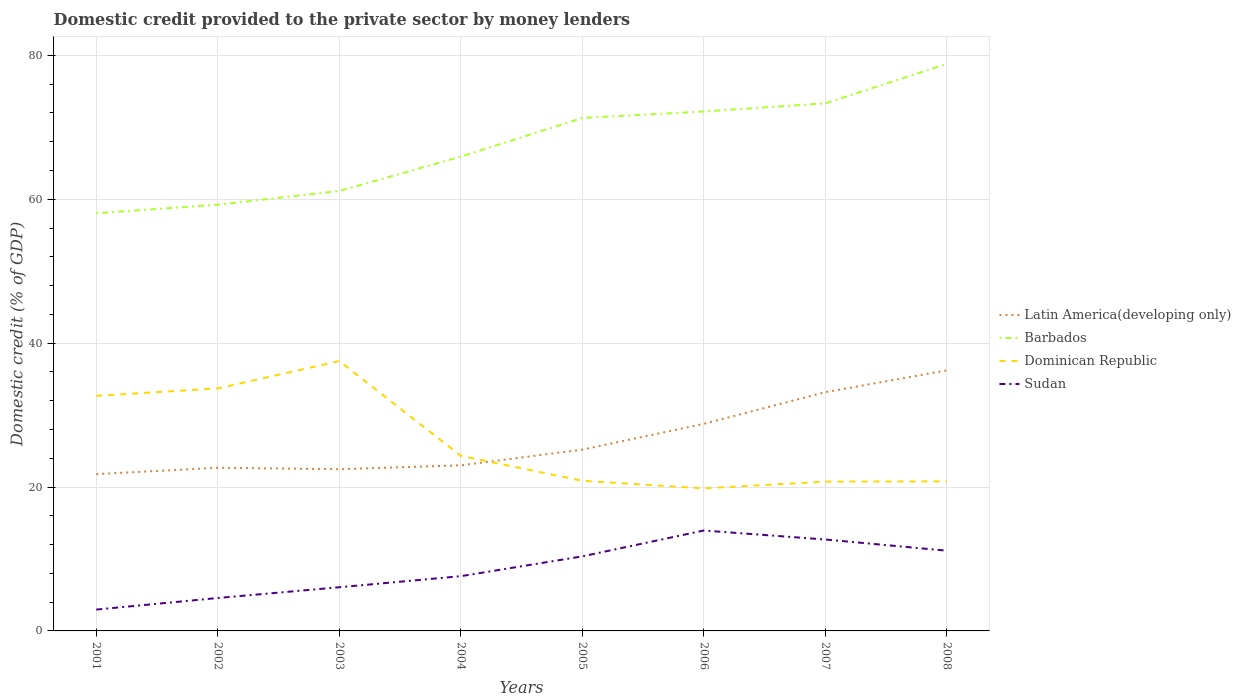Across all years, what is the maximum domestic credit provided to the private sector by money lenders in Barbados?
Provide a short and direct response. 58.07. What is the total domestic credit provided to the private sector by money lenders in Sudan in the graph?
Make the answer very short. 1.56. What is the difference between the highest and the second highest domestic credit provided to the private sector by money lenders in Dominican Republic?
Offer a very short reply. 17.7. Is the domestic credit provided to the private sector by money lenders in Barbados strictly greater than the domestic credit provided to the private sector by money lenders in Sudan over the years?
Provide a succinct answer. No. What is the difference between two consecutive major ticks on the Y-axis?
Your answer should be compact. 20. Are the values on the major ticks of Y-axis written in scientific E-notation?
Give a very brief answer. No. Does the graph contain any zero values?
Ensure brevity in your answer.  No. How many legend labels are there?
Make the answer very short. 4. How are the legend labels stacked?
Ensure brevity in your answer.  Vertical. What is the title of the graph?
Ensure brevity in your answer.  Domestic credit provided to the private sector by money lenders. Does "Djibouti" appear as one of the legend labels in the graph?
Offer a terse response. No. What is the label or title of the Y-axis?
Provide a succinct answer. Domestic credit (% of GDP). What is the Domestic credit (% of GDP) in Latin America(developing only) in 2001?
Ensure brevity in your answer.  21.8. What is the Domestic credit (% of GDP) of Barbados in 2001?
Provide a short and direct response. 58.07. What is the Domestic credit (% of GDP) in Dominican Republic in 2001?
Offer a terse response. 32.68. What is the Domestic credit (% of GDP) in Sudan in 2001?
Ensure brevity in your answer.  2.97. What is the Domestic credit (% of GDP) of Latin America(developing only) in 2002?
Provide a succinct answer. 22.68. What is the Domestic credit (% of GDP) of Barbados in 2002?
Ensure brevity in your answer.  59.25. What is the Domestic credit (% of GDP) in Dominican Republic in 2002?
Your answer should be compact. 33.71. What is the Domestic credit (% of GDP) of Sudan in 2002?
Offer a very short reply. 4.58. What is the Domestic credit (% of GDP) in Latin America(developing only) in 2003?
Your answer should be compact. 22.48. What is the Domestic credit (% of GDP) of Barbados in 2003?
Your answer should be very brief. 61.15. What is the Domestic credit (% of GDP) in Dominican Republic in 2003?
Give a very brief answer. 37.51. What is the Domestic credit (% of GDP) of Sudan in 2003?
Ensure brevity in your answer.  6.07. What is the Domestic credit (% of GDP) of Latin America(developing only) in 2004?
Your answer should be compact. 23.02. What is the Domestic credit (% of GDP) of Barbados in 2004?
Make the answer very short. 65.93. What is the Domestic credit (% of GDP) in Dominican Republic in 2004?
Offer a terse response. 24.34. What is the Domestic credit (% of GDP) in Sudan in 2004?
Offer a terse response. 7.61. What is the Domestic credit (% of GDP) of Latin America(developing only) in 2005?
Offer a very short reply. 25.2. What is the Domestic credit (% of GDP) of Barbados in 2005?
Provide a short and direct response. 71.31. What is the Domestic credit (% of GDP) of Dominican Republic in 2005?
Make the answer very short. 20.87. What is the Domestic credit (% of GDP) in Sudan in 2005?
Keep it short and to the point. 10.36. What is the Domestic credit (% of GDP) in Latin America(developing only) in 2006?
Give a very brief answer. 28.79. What is the Domestic credit (% of GDP) of Barbados in 2006?
Your answer should be very brief. 72.21. What is the Domestic credit (% of GDP) of Dominican Republic in 2006?
Make the answer very short. 19.82. What is the Domestic credit (% of GDP) of Sudan in 2006?
Give a very brief answer. 13.96. What is the Domestic credit (% of GDP) of Latin America(developing only) in 2007?
Your answer should be compact. 33.19. What is the Domestic credit (% of GDP) of Barbados in 2007?
Your answer should be compact. 73.35. What is the Domestic credit (% of GDP) of Dominican Republic in 2007?
Keep it short and to the point. 20.75. What is the Domestic credit (% of GDP) of Sudan in 2007?
Your answer should be very brief. 12.71. What is the Domestic credit (% of GDP) in Latin America(developing only) in 2008?
Ensure brevity in your answer.  36.22. What is the Domestic credit (% of GDP) of Barbados in 2008?
Offer a terse response. 78.83. What is the Domestic credit (% of GDP) in Dominican Republic in 2008?
Your answer should be very brief. 20.79. What is the Domestic credit (% of GDP) of Sudan in 2008?
Make the answer very short. 11.15. Across all years, what is the maximum Domestic credit (% of GDP) in Latin America(developing only)?
Provide a succinct answer. 36.22. Across all years, what is the maximum Domestic credit (% of GDP) in Barbados?
Offer a very short reply. 78.83. Across all years, what is the maximum Domestic credit (% of GDP) in Dominican Republic?
Keep it short and to the point. 37.51. Across all years, what is the maximum Domestic credit (% of GDP) in Sudan?
Your answer should be compact. 13.96. Across all years, what is the minimum Domestic credit (% of GDP) in Latin America(developing only)?
Keep it short and to the point. 21.8. Across all years, what is the minimum Domestic credit (% of GDP) in Barbados?
Give a very brief answer. 58.07. Across all years, what is the minimum Domestic credit (% of GDP) in Dominican Republic?
Provide a succinct answer. 19.82. Across all years, what is the minimum Domestic credit (% of GDP) in Sudan?
Provide a short and direct response. 2.97. What is the total Domestic credit (% of GDP) of Latin America(developing only) in the graph?
Provide a short and direct response. 213.38. What is the total Domestic credit (% of GDP) of Barbados in the graph?
Keep it short and to the point. 540.09. What is the total Domestic credit (% of GDP) of Dominican Republic in the graph?
Your answer should be very brief. 210.47. What is the total Domestic credit (% of GDP) of Sudan in the graph?
Keep it short and to the point. 69.41. What is the difference between the Domestic credit (% of GDP) in Latin America(developing only) in 2001 and that in 2002?
Your answer should be compact. -0.88. What is the difference between the Domestic credit (% of GDP) of Barbados in 2001 and that in 2002?
Provide a succinct answer. -1.18. What is the difference between the Domestic credit (% of GDP) of Dominican Republic in 2001 and that in 2002?
Provide a succinct answer. -1.04. What is the difference between the Domestic credit (% of GDP) in Sudan in 2001 and that in 2002?
Give a very brief answer. -1.61. What is the difference between the Domestic credit (% of GDP) in Latin America(developing only) in 2001 and that in 2003?
Keep it short and to the point. -0.68. What is the difference between the Domestic credit (% of GDP) of Barbados in 2001 and that in 2003?
Ensure brevity in your answer.  -3.08. What is the difference between the Domestic credit (% of GDP) of Dominican Republic in 2001 and that in 2003?
Keep it short and to the point. -4.84. What is the difference between the Domestic credit (% of GDP) of Sudan in 2001 and that in 2003?
Make the answer very short. -3.11. What is the difference between the Domestic credit (% of GDP) in Latin America(developing only) in 2001 and that in 2004?
Ensure brevity in your answer.  -1.23. What is the difference between the Domestic credit (% of GDP) of Barbados in 2001 and that in 2004?
Ensure brevity in your answer.  -7.86. What is the difference between the Domestic credit (% of GDP) in Dominican Republic in 2001 and that in 2004?
Offer a terse response. 8.33. What is the difference between the Domestic credit (% of GDP) in Sudan in 2001 and that in 2004?
Your response must be concise. -4.64. What is the difference between the Domestic credit (% of GDP) in Latin America(developing only) in 2001 and that in 2005?
Ensure brevity in your answer.  -3.4. What is the difference between the Domestic credit (% of GDP) of Barbados in 2001 and that in 2005?
Offer a very short reply. -13.24. What is the difference between the Domestic credit (% of GDP) in Dominican Republic in 2001 and that in 2005?
Give a very brief answer. 11.8. What is the difference between the Domestic credit (% of GDP) in Sudan in 2001 and that in 2005?
Make the answer very short. -7.4. What is the difference between the Domestic credit (% of GDP) in Latin America(developing only) in 2001 and that in 2006?
Give a very brief answer. -6.99. What is the difference between the Domestic credit (% of GDP) of Barbados in 2001 and that in 2006?
Your answer should be very brief. -14.14. What is the difference between the Domestic credit (% of GDP) of Dominican Republic in 2001 and that in 2006?
Make the answer very short. 12.86. What is the difference between the Domestic credit (% of GDP) in Sudan in 2001 and that in 2006?
Your answer should be very brief. -10.99. What is the difference between the Domestic credit (% of GDP) in Latin America(developing only) in 2001 and that in 2007?
Offer a very short reply. -11.39. What is the difference between the Domestic credit (% of GDP) in Barbados in 2001 and that in 2007?
Offer a very short reply. -15.28. What is the difference between the Domestic credit (% of GDP) of Dominican Republic in 2001 and that in 2007?
Provide a succinct answer. 11.92. What is the difference between the Domestic credit (% of GDP) of Sudan in 2001 and that in 2007?
Your response must be concise. -9.74. What is the difference between the Domestic credit (% of GDP) in Latin America(developing only) in 2001 and that in 2008?
Ensure brevity in your answer.  -14.43. What is the difference between the Domestic credit (% of GDP) of Barbados in 2001 and that in 2008?
Keep it short and to the point. -20.76. What is the difference between the Domestic credit (% of GDP) in Dominican Republic in 2001 and that in 2008?
Offer a very short reply. 11.89. What is the difference between the Domestic credit (% of GDP) in Sudan in 2001 and that in 2008?
Provide a succinct answer. -8.19. What is the difference between the Domestic credit (% of GDP) of Latin America(developing only) in 2002 and that in 2003?
Provide a succinct answer. 0.2. What is the difference between the Domestic credit (% of GDP) in Barbados in 2002 and that in 2003?
Give a very brief answer. -1.91. What is the difference between the Domestic credit (% of GDP) in Dominican Republic in 2002 and that in 2003?
Your answer should be compact. -3.8. What is the difference between the Domestic credit (% of GDP) in Sudan in 2002 and that in 2003?
Offer a very short reply. -1.49. What is the difference between the Domestic credit (% of GDP) of Latin America(developing only) in 2002 and that in 2004?
Ensure brevity in your answer.  -0.35. What is the difference between the Domestic credit (% of GDP) of Barbados in 2002 and that in 2004?
Offer a very short reply. -6.68. What is the difference between the Domestic credit (% of GDP) in Dominican Republic in 2002 and that in 2004?
Provide a succinct answer. 9.37. What is the difference between the Domestic credit (% of GDP) in Sudan in 2002 and that in 2004?
Make the answer very short. -3.03. What is the difference between the Domestic credit (% of GDP) in Latin America(developing only) in 2002 and that in 2005?
Provide a succinct answer. -2.52. What is the difference between the Domestic credit (% of GDP) of Barbados in 2002 and that in 2005?
Ensure brevity in your answer.  -12.06. What is the difference between the Domestic credit (% of GDP) of Dominican Republic in 2002 and that in 2005?
Make the answer very short. 12.84. What is the difference between the Domestic credit (% of GDP) in Sudan in 2002 and that in 2005?
Your answer should be very brief. -5.79. What is the difference between the Domestic credit (% of GDP) in Latin America(developing only) in 2002 and that in 2006?
Your answer should be very brief. -6.11. What is the difference between the Domestic credit (% of GDP) of Barbados in 2002 and that in 2006?
Make the answer very short. -12.96. What is the difference between the Domestic credit (% of GDP) in Dominican Republic in 2002 and that in 2006?
Your response must be concise. 13.89. What is the difference between the Domestic credit (% of GDP) in Sudan in 2002 and that in 2006?
Make the answer very short. -9.38. What is the difference between the Domestic credit (% of GDP) in Latin America(developing only) in 2002 and that in 2007?
Ensure brevity in your answer.  -10.51. What is the difference between the Domestic credit (% of GDP) in Barbados in 2002 and that in 2007?
Make the answer very short. -14.1. What is the difference between the Domestic credit (% of GDP) of Dominican Republic in 2002 and that in 2007?
Your response must be concise. 12.96. What is the difference between the Domestic credit (% of GDP) of Sudan in 2002 and that in 2007?
Provide a succinct answer. -8.13. What is the difference between the Domestic credit (% of GDP) of Latin America(developing only) in 2002 and that in 2008?
Your answer should be very brief. -13.55. What is the difference between the Domestic credit (% of GDP) of Barbados in 2002 and that in 2008?
Your answer should be very brief. -19.58. What is the difference between the Domestic credit (% of GDP) in Dominican Republic in 2002 and that in 2008?
Provide a succinct answer. 12.93. What is the difference between the Domestic credit (% of GDP) in Sudan in 2002 and that in 2008?
Offer a very short reply. -6.58. What is the difference between the Domestic credit (% of GDP) in Latin America(developing only) in 2003 and that in 2004?
Your answer should be compact. -0.54. What is the difference between the Domestic credit (% of GDP) of Barbados in 2003 and that in 2004?
Keep it short and to the point. -4.77. What is the difference between the Domestic credit (% of GDP) in Dominican Republic in 2003 and that in 2004?
Offer a terse response. 13.17. What is the difference between the Domestic credit (% of GDP) of Sudan in 2003 and that in 2004?
Provide a succinct answer. -1.54. What is the difference between the Domestic credit (% of GDP) in Latin America(developing only) in 2003 and that in 2005?
Offer a very short reply. -2.72. What is the difference between the Domestic credit (% of GDP) in Barbados in 2003 and that in 2005?
Keep it short and to the point. -10.15. What is the difference between the Domestic credit (% of GDP) in Dominican Republic in 2003 and that in 2005?
Offer a very short reply. 16.64. What is the difference between the Domestic credit (% of GDP) in Sudan in 2003 and that in 2005?
Offer a terse response. -4.29. What is the difference between the Domestic credit (% of GDP) of Latin America(developing only) in 2003 and that in 2006?
Give a very brief answer. -6.31. What is the difference between the Domestic credit (% of GDP) of Barbados in 2003 and that in 2006?
Your answer should be compact. -11.05. What is the difference between the Domestic credit (% of GDP) in Dominican Republic in 2003 and that in 2006?
Give a very brief answer. 17.7. What is the difference between the Domestic credit (% of GDP) in Sudan in 2003 and that in 2006?
Make the answer very short. -7.89. What is the difference between the Domestic credit (% of GDP) in Latin America(developing only) in 2003 and that in 2007?
Provide a succinct answer. -10.71. What is the difference between the Domestic credit (% of GDP) of Barbados in 2003 and that in 2007?
Offer a very short reply. -12.19. What is the difference between the Domestic credit (% of GDP) of Dominican Republic in 2003 and that in 2007?
Your answer should be compact. 16.76. What is the difference between the Domestic credit (% of GDP) of Sudan in 2003 and that in 2007?
Provide a succinct answer. -6.64. What is the difference between the Domestic credit (% of GDP) in Latin America(developing only) in 2003 and that in 2008?
Give a very brief answer. -13.74. What is the difference between the Domestic credit (% of GDP) of Barbados in 2003 and that in 2008?
Provide a succinct answer. -17.67. What is the difference between the Domestic credit (% of GDP) in Dominican Republic in 2003 and that in 2008?
Ensure brevity in your answer.  16.73. What is the difference between the Domestic credit (% of GDP) in Sudan in 2003 and that in 2008?
Your response must be concise. -5.08. What is the difference between the Domestic credit (% of GDP) of Latin America(developing only) in 2004 and that in 2005?
Give a very brief answer. -2.18. What is the difference between the Domestic credit (% of GDP) of Barbados in 2004 and that in 2005?
Make the answer very short. -5.38. What is the difference between the Domestic credit (% of GDP) in Dominican Republic in 2004 and that in 2005?
Make the answer very short. 3.47. What is the difference between the Domestic credit (% of GDP) of Sudan in 2004 and that in 2005?
Offer a terse response. -2.75. What is the difference between the Domestic credit (% of GDP) of Latin America(developing only) in 2004 and that in 2006?
Your response must be concise. -5.76. What is the difference between the Domestic credit (% of GDP) in Barbados in 2004 and that in 2006?
Provide a short and direct response. -6.28. What is the difference between the Domestic credit (% of GDP) of Dominican Republic in 2004 and that in 2006?
Provide a short and direct response. 4.52. What is the difference between the Domestic credit (% of GDP) in Sudan in 2004 and that in 2006?
Ensure brevity in your answer.  -6.35. What is the difference between the Domestic credit (% of GDP) in Latin America(developing only) in 2004 and that in 2007?
Provide a short and direct response. -10.17. What is the difference between the Domestic credit (% of GDP) of Barbados in 2004 and that in 2007?
Give a very brief answer. -7.42. What is the difference between the Domestic credit (% of GDP) of Dominican Republic in 2004 and that in 2007?
Keep it short and to the point. 3.59. What is the difference between the Domestic credit (% of GDP) of Sudan in 2004 and that in 2007?
Give a very brief answer. -5.1. What is the difference between the Domestic credit (% of GDP) of Latin America(developing only) in 2004 and that in 2008?
Give a very brief answer. -13.2. What is the difference between the Domestic credit (% of GDP) of Barbados in 2004 and that in 2008?
Your answer should be compact. -12.9. What is the difference between the Domestic credit (% of GDP) in Dominican Republic in 2004 and that in 2008?
Provide a short and direct response. 3.56. What is the difference between the Domestic credit (% of GDP) in Sudan in 2004 and that in 2008?
Your answer should be compact. -3.54. What is the difference between the Domestic credit (% of GDP) in Latin America(developing only) in 2005 and that in 2006?
Provide a succinct answer. -3.59. What is the difference between the Domestic credit (% of GDP) of Barbados in 2005 and that in 2006?
Offer a very short reply. -0.9. What is the difference between the Domestic credit (% of GDP) of Dominican Republic in 2005 and that in 2006?
Provide a succinct answer. 1.05. What is the difference between the Domestic credit (% of GDP) in Sudan in 2005 and that in 2006?
Offer a terse response. -3.6. What is the difference between the Domestic credit (% of GDP) of Latin America(developing only) in 2005 and that in 2007?
Your answer should be very brief. -7.99. What is the difference between the Domestic credit (% of GDP) in Barbados in 2005 and that in 2007?
Provide a succinct answer. -2.04. What is the difference between the Domestic credit (% of GDP) in Dominican Republic in 2005 and that in 2007?
Offer a very short reply. 0.12. What is the difference between the Domestic credit (% of GDP) in Sudan in 2005 and that in 2007?
Make the answer very short. -2.34. What is the difference between the Domestic credit (% of GDP) in Latin America(developing only) in 2005 and that in 2008?
Give a very brief answer. -11.02. What is the difference between the Domestic credit (% of GDP) of Barbados in 2005 and that in 2008?
Your answer should be very brief. -7.52. What is the difference between the Domestic credit (% of GDP) in Dominican Republic in 2005 and that in 2008?
Keep it short and to the point. 0.09. What is the difference between the Domestic credit (% of GDP) of Sudan in 2005 and that in 2008?
Your answer should be compact. -0.79. What is the difference between the Domestic credit (% of GDP) of Latin America(developing only) in 2006 and that in 2007?
Provide a succinct answer. -4.4. What is the difference between the Domestic credit (% of GDP) in Barbados in 2006 and that in 2007?
Ensure brevity in your answer.  -1.14. What is the difference between the Domestic credit (% of GDP) of Dominican Republic in 2006 and that in 2007?
Offer a terse response. -0.94. What is the difference between the Domestic credit (% of GDP) of Sudan in 2006 and that in 2007?
Your answer should be very brief. 1.25. What is the difference between the Domestic credit (% of GDP) in Latin America(developing only) in 2006 and that in 2008?
Provide a succinct answer. -7.44. What is the difference between the Domestic credit (% of GDP) in Barbados in 2006 and that in 2008?
Provide a succinct answer. -6.62. What is the difference between the Domestic credit (% of GDP) in Dominican Republic in 2006 and that in 2008?
Provide a succinct answer. -0.97. What is the difference between the Domestic credit (% of GDP) of Sudan in 2006 and that in 2008?
Your answer should be very brief. 2.81. What is the difference between the Domestic credit (% of GDP) in Latin America(developing only) in 2007 and that in 2008?
Give a very brief answer. -3.03. What is the difference between the Domestic credit (% of GDP) of Barbados in 2007 and that in 2008?
Keep it short and to the point. -5.48. What is the difference between the Domestic credit (% of GDP) of Dominican Republic in 2007 and that in 2008?
Ensure brevity in your answer.  -0.03. What is the difference between the Domestic credit (% of GDP) of Sudan in 2007 and that in 2008?
Provide a succinct answer. 1.56. What is the difference between the Domestic credit (% of GDP) of Latin America(developing only) in 2001 and the Domestic credit (% of GDP) of Barbados in 2002?
Your answer should be compact. -37.45. What is the difference between the Domestic credit (% of GDP) in Latin America(developing only) in 2001 and the Domestic credit (% of GDP) in Dominican Republic in 2002?
Your answer should be very brief. -11.91. What is the difference between the Domestic credit (% of GDP) in Latin America(developing only) in 2001 and the Domestic credit (% of GDP) in Sudan in 2002?
Provide a succinct answer. 17.22. What is the difference between the Domestic credit (% of GDP) in Barbados in 2001 and the Domestic credit (% of GDP) in Dominican Republic in 2002?
Your response must be concise. 24.36. What is the difference between the Domestic credit (% of GDP) of Barbados in 2001 and the Domestic credit (% of GDP) of Sudan in 2002?
Offer a terse response. 53.49. What is the difference between the Domestic credit (% of GDP) in Dominican Republic in 2001 and the Domestic credit (% of GDP) in Sudan in 2002?
Provide a succinct answer. 28.1. What is the difference between the Domestic credit (% of GDP) in Latin America(developing only) in 2001 and the Domestic credit (% of GDP) in Barbados in 2003?
Your response must be concise. -39.36. What is the difference between the Domestic credit (% of GDP) in Latin America(developing only) in 2001 and the Domestic credit (% of GDP) in Dominican Republic in 2003?
Your answer should be compact. -15.72. What is the difference between the Domestic credit (% of GDP) in Latin America(developing only) in 2001 and the Domestic credit (% of GDP) in Sudan in 2003?
Make the answer very short. 15.73. What is the difference between the Domestic credit (% of GDP) of Barbados in 2001 and the Domestic credit (% of GDP) of Dominican Republic in 2003?
Provide a succinct answer. 20.56. What is the difference between the Domestic credit (% of GDP) in Barbados in 2001 and the Domestic credit (% of GDP) in Sudan in 2003?
Give a very brief answer. 52. What is the difference between the Domestic credit (% of GDP) of Dominican Republic in 2001 and the Domestic credit (% of GDP) of Sudan in 2003?
Provide a succinct answer. 26.6. What is the difference between the Domestic credit (% of GDP) of Latin America(developing only) in 2001 and the Domestic credit (% of GDP) of Barbados in 2004?
Make the answer very short. -44.13. What is the difference between the Domestic credit (% of GDP) of Latin America(developing only) in 2001 and the Domestic credit (% of GDP) of Dominican Republic in 2004?
Your answer should be very brief. -2.54. What is the difference between the Domestic credit (% of GDP) of Latin America(developing only) in 2001 and the Domestic credit (% of GDP) of Sudan in 2004?
Ensure brevity in your answer.  14.19. What is the difference between the Domestic credit (% of GDP) in Barbados in 2001 and the Domestic credit (% of GDP) in Dominican Republic in 2004?
Your response must be concise. 33.73. What is the difference between the Domestic credit (% of GDP) of Barbados in 2001 and the Domestic credit (% of GDP) of Sudan in 2004?
Offer a terse response. 50.46. What is the difference between the Domestic credit (% of GDP) in Dominican Republic in 2001 and the Domestic credit (% of GDP) in Sudan in 2004?
Your answer should be very brief. 25.07. What is the difference between the Domestic credit (% of GDP) of Latin America(developing only) in 2001 and the Domestic credit (% of GDP) of Barbados in 2005?
Make the answer very short. -49.51. What is the difference between the Domestic credit (% of GDP) of Latin America(developing only) in 2001 and the Domestic credit (% of GDP) of Dominican Republic in 2005?
Provide a short and direct response. 0.93. What is the difference between the Domestic credit (% of GDP) in Latin America(developing only) in 2001 and the Domestic credit (% of GDP) in Sudan in 2005?
Offer a very short reply. 11.43. What is the difference between the Domestic credit (% of GDP) in Barbados in 2001 and the Domestic credit (% of GDP) in Dominican Republic in 2005?
Give a very brief answer. 37.2. What is the difference between the Domestic credit (% of GDP) of Barbados in 2001 and the Domestic credit (% of GDP) of Sudan in 2005?
Give a very brief answer. 47.71. What is the difference between the Domestic credit (% of GDP) of Dominican Republic in 2001 and the Domestic credit (% of GDP) of Sudan in 2005?
Offer a very short reply. 22.31. What is the difference between the Domestic credit (% of GDP) in Latin America(developing only) in 2001 and the Domestic credit (% of GDP) in Barbados in 2006?
Keep it short and to the point. -50.41. What is the difference between the Domestic credit (% of GDP) in Latin America(developing only) in 2001 and the Domestic credit (% of GDP) in Dominican Republic in 2006?
Offer a very short reply. 1.98. What is the difference between the Domestic credit (% of GDP) in Latin America(developing only) in 2001 and the Domestic credit (% of GDP) in Sudan in 2006?
Your answer should be compact. 7.84. What is the difference between the Domestic credit (% of GDP) in Barbados in 2001 and the Domestic credit (% of GDP) in Dominican Republic in 2006?
Offer a terse response. 38.25. What is the difference between the Domestic credit (% of GDP) of Barbados in 2001 and the Domestic credit (% of GDP) of Sudan in 2006?
Your answer should be very brief. 44.11. What is the difference between the Domestic credit (% of GDP) in Dominican Republic in 2001 and the Domestic credit (% of GDP) in Sudan in 2006?
Give a very brief answer. 18.72. What is the difference between the Domestic credit (% of GDP) in Latin America(developing only) in 2001 and the Domestic credit (% of GDP) in Barbados in 2007?
Give a very brief answer. -51.55. What is the difference between the Domestic credit (% of GDP) of Latin America(developing only) in 2001 and the Domestic credit (% of GDP) of Dominican Republic in 2007?
Provide a succinct answer. 1.04. What is the difference between the Domestic credit (% of GDP) of Latin America(developing only) in 2001 and the Domestic credit (% of GDP) of Sudan in 2007?
Your answer should be very brief. 9.09. What is the difference between the Domestic credit (% of GDP) in Barbados in 2001 and the Domestic credit (% of GDP) in Dominican Republic in 2007?
Make the answer very short. 37.32. What is the difference between the Domestic credit (% of GDP) in Barbados in 2001 and the Domestic credit (% of GDP) in Sudan in 2007?
Provide a succinct answer. 45.36. What is the difference between the Domestic credit (% of GDP) of Dominican Republic in 2001 and the Domestic credit (% of GDP) of Sudan in 2007?
Your answer should be compact. 19.97. What is the difference between the Domestic credit (% of GDP) in Latin America(developing only) in 2001 and the Domestic credit (% of GDP) in Barbados in 2008?
Offer a very short reply. -57.03. What is the difference between the Domestic credit (% of GDP) in Latin America(developing only) in 2001 and the Domestic credit (% of GDP) in Dominican Republic in 2008?
Offer a terse response. 1.01. What is the difference between the Domestic credit (% of GDP) in Latin America(developing only) in 2001 and the Domestic credit (% of GDP) in Sudan in 2008?
Provide a succinct answer. 10.64. What is the difference between the Domestic credit (% of GDP) in Barbados in 2001 and the Domestic credit (% of GDP) in Dominican Republic in 2008?
Ensure brevity in your answer.  37.28. What is the difference between the Domestic credit (% of GDP) of Barbados in 2001 and the Domestic credit (% of GDP) of Sudan in 2008?
Provide a short and direct response. 46.92. What is the difference between the Domestic credit (% of GDP) of Dominican Republic in 2001 and the Domestic credit (% of GDP) of Sudan in 2008?
Give a very brief answer. 21.52. What is the difference between the Domestic credit (% of GDP) of Latin America(developing only) in 2002 and the Domestic credit (% of GDP) of Barbados in 2003?
Ensure brevity in your answer.  -38.48. What is the difference between the Domestic credit (% of GDP) in Latin America(developing only) in 2002 and the Domestic credit (% of GDP) in Dominican Republic in 2003?
Your answer should be compact. -14.84. What is the difference between the Domestic credit (% of GDP) of Latin America(developing only) in 2002 and the Domestic credit (% of GDP) of Sudan in 2003?
Give a very brief answer. 16.61. What is the difference between the Domestic credit (% of GDP) in Barbados in 2002 and the Domestic credit (% of GDP) in Dominican Republic in 2003?
Your response must be concise. 21.74. What is the difference between the Domestic credit (% of GDP) in Barbados in 2002 and the Domestic credit (% of GDP) in Sudan in 2003?
Your response must be concise. 53.18. What is the difference between the Domestic credit (% of GDP) of Dominican Republic in 2002 and the Domestic credit (% of GDP) of Sudan in 2003?
Make the answer very short. 27.64. What is the difference between the Domestic credit (% of GDP) in Latin America(developing only) in 2002 and the Domestic credit (% of GDP) in Barbados in 2004?
Your response must be concise. -43.25. What is the difference between the Domestic credit (% of GDP) of Latin America(developing only) in 2002 and the Domestic credit (% of GDP) of Dominican Republic in 2004?
Offer a terse response. -1.66. What is the difference between the Domestic credit (% of GDP) of Latin America(developing only) in 2002 and the Domestic credit (% of GDP) of Sudan in 2004?
Offer a very short reply. 15.07. What is the difference between the Domestic credit (% of GDP) of Barbados in 2002 and the Domestic credit (% of GDP) of Dominican Republic in 2004?
Offer a terse response. 34.91. What is the difference between the Domestic credit (% of GDP) of Barbados in 2002 and the Domestic credit (% of GDP) of Sudan in 2004?
Your answer should be very brief. 51.64. What is the difference between the Domestic credit (% of GDP) of Dominican Republic in 2002 and the Domestic credit (% of GDP) of Sudan in 2004?
Keep it short and to the point. 26.1. What is the difference between the Domestic credit (% of GDP) in Latin America(developing only) in 2002 and the Domestic credit (% of GDP) in Barbados in 2005?
Give a very brief answer. -48.63. What is the difference between the Domestic credit (% of GDP) of Latin America(developing only) in 2002 and the Domestic credit (% of GDP) of Dominican Republic in 2005?
Your response must be concise. 1.81. What is the difference between the Domestic credit (% of GDP) of Latin America(developing only) in 2002 and the Domestic credit (% of GDP) of Sudan in 2005?
Offer a terse response. 12.31. What is the difference between the Domestic credit (% of GDP) of Barbados in 2002 and the Domestic credit (% of GDP) of Dominican Republic in 2005?
Make the answer very short. 38.38. What is the difference between the Domestic credit (% of GDP) in Barbados in 2002 and the Domestic credit (% of GDP) in Sudan in 2005?
Your answer should be very brief. 48.88. What is the difference between the Domestic credit (% of GDP) in Dominican Republic in 2002 and the Domestic credit (% of GDP) in Sudan in 2005?
Make the answer very short. 23.35. What is the difference between the Domestic credit (% of GDP) of Latin America(developing only) in 2002 and the Domestic credit (% of GDP) of Barbados in 2006?
Your answer should be compact. -49.53. What is the difference between the Domestic credit (% of GDP) in Latin America(developing only) in 2002 and the Domestic credit (% of GDP) in Dominican Republic in 2006?
Your answer should be very brief. 2.86. What is the difference between the Domestic credit (% of GDP) of Latin America(developing only) in 2002 and the Domestic credit (% of GDP) of Sudan in 2006?
Keep it short and to the point. 8.72. What is the difference between the Domestic credit (% of GDP) of Barbados in 2002 and the Domestic credit (% of GDP) of Dominican Republic in 2006?
Your response must be concise. 39.43. What is the difference between the Domestic credit (% of GDP) of Barbados in 2002 and the Domestic credit (% of GDP) of Sudan in 2006?
Give a very brief answer. 45.29. What is the difference between the Domestic credit (% of GDP) of Dominican Republic in 2002 and the Domestic credit (% of GDP) of Sudan in 2006?
Give a very brief answer. 19.75. What is the difference between the Domestic credit (% of GDP) of Latin America(developing only) in 2002 and the Domestic credit (% of GDP) of Barbados in 2007?
Ensure brevity in your answer.  -50.67. What is the difference between the Domestic credit (% of GDP) of Latin America(developing only) in 2002 and the Domestic credit (% of GDP) of Dominican Republic in 2007?
Your response must be concise. 1.92. What is the difference between the Domestic credit (% of GDP) of Latin America(developing only) in 2002 and the Domestic credit (% of GDP) of Sudan in 2007?
Your answer should be compact. 9.97. What is the difference between the Domestic credit (% of GDP) of Barbados in 2002 and the Domestic credit (% of GDP) of Dominican Republic in 2007?
Provide a succinct answer. 38.5. What is the difference between the Domestic credit (% of GDP) in Barbados in 2002 and the Domestic credit (% of GDP) in Sudan in 2007?
Ensure brevity in your answer.  46.54. What is the difference between the Domestic credit (% of GDP) in Dominican Republic in 2002 and the Domestic credit (% of GDP) in Sudan in 2007?
Offer a very short reply. 21. What is the difference between the Domestic credit (% of GDP) in Latin America(developing only) in 2002 and the Domestic credit (% of GDP) in Barbados in 2008?
Offer a terse response. -56.15. What is the difference between the Domestic credit (% of GDP) of Latin America(developing only) in 2002 and the Domestic credit (% of GDP) of Dominican Republic in 2008?
Provide a short and direct response. 1.89. What is the difference between the Domestic credit (% of GDP) of Latin America(developing only) in 2002 and the Domestic credit (% of GDP) of Sudan in 2008?
Offer a terse response. 11.52. What is the difference between the Domestic credit (% of GDP) in Barbados in 2002 and the Domestic credit (% of GDP) in Dominican Republic in 2008?
Ensure brevity in your answer.  38.46. What is the difference between the Domestic credit (% of GDP) in Barbados in 2002 and the Domestic credit (% of GDP) in Sudan in 2008?
Provide a short and direct response. 48.1. What is the difference between the Domestic credit (% of GDP) in Dominican Republic in 2002 and the Domestic credit (% of GDP) in Sudan in 2008?
Make the answer very short. 22.56. What is the difference between the Domestic credit (% of GDP) in Latin America(developing only) in 2003 and the Domestic credit (% of GDP) in Barbados in 2004?
Keep it short and to the point. -43.45. What is the difference between the Domestic credit (% of GDP) in Latin America(developing only) in 2003 and the Domestic credit (% of GDP) in Dominican Republic in 2004?
Give a very brief answer. -1.86. What is the difference between the Domestic credit (% of GDP) of Latin America(developing only) in 2003 and the Domestic credit (% of GDP) of Sudan in 2004?
Provide a succinct answer. 14.87. What is the difference between the Domestic credit (% of GDP) in Barbados in 2003 and the Domestic credit (% of GDP) in Dominican Republic in 2004?
Offer a terse response. 36.81. What is the difference between the Domestic credit (% of GDP) in Barbados in 2003 and the Domestic credit (% of GDP) in Sudan in 2004?
Provide a short and direct response. 53.54. What is the difference between the Domestic credit (% of GDP) in Dominican Republic in 2003 and the Domestic credit (% of GDP) in Sudan in 2004?
Ensure brevity in your answer.  29.9. What is the difference between the Domestic credit (% of GDP) of Latin America(developing only) in 2003 and the Domestic credit (% of GDP) of Barbados in 2005?
Offer a terse response. -48.83. What is the difference between the Domestic credit (% of GDP) of Latin America(developing only) in 2003 and the Domestic credit (% of GDP) of Dominican Republic in 2005?
Your response must be concise. 1.61. What is the difference between the Domestic credit (% of GDP) in Latin America(developing only) in 2003 and the Domestic credit (% of GDP) in Sudan in 2005?
Provide a succinct answer. 12.12. What is the difference between the Domestic credit (% of GDP) in Barbados in 2003 and the Domestic credit (% of GDP) in Dominican Republic in 2005?
Offer a terse response. 40.28. What is the difference between the Domestic credit (% of GDP) in Barbados in 2003 and the Domestic credit (% of GDP) in Sudan in 2005?
Provide a short and direct response. 50.79. What is the difference between the Domestic credit (% of GDP) in Dominican Republic in 2003 and the Domestic credit (% of GDP) in Sudan in 2005?
Offer a terse response. 27.15. What is the difference between the Domestic credit (% of GDP) of Latin America(developing only) in 2003 and the Domestic credit (% of GDP) of Barbados in 2006?
Your answer should be compact. -49.73. What is the difference between the Domestic credit (% of GDP) in Latin America(developing only) in 2003 and the Domestic credit (% of GDP) in Dominican Republic in 2006?
Offer a terse response. 2.66. What is the difference between the Domestic credit (% of GDP) of Latin America(developing only) in 2003 and the Domestic credit (% of GDP) of Sudan in 2006?
Give a very brief answer. 8.52. What is the difference between the Domestic credit (% of GDP) in Barbados in 2003 and the Domestic credit (% of GDP) in Dominican Republic in 2006?
Provide a short and direct response. 41.34. What is the difference between the Domestic credit (% of GDP) in Barbados in 2003 and the Domestic credit (% of GDP) in Sudan in 2006?
Keep it short and to the point. 47.19. What is the difference between the Domestic credit (% of GDP) in Dominican Republic in 2003 and the Domestic credit (% of GDP) in Sudan in 2006?
Give a very brief answer. 23.55. What is the difference between the Domestic credit (% of GDP) of Latin America(developing only) in 2003 and the Domestic credit (% of GDP) of Barbados in 2007?
Make the answer very short. -50.87. What is the difference between the Domestic credit (% of GDP) of Latin America(developing only) in 2003 and the Domestic credit (% of GDP) of Dominican Republic in 2007?
Offer a terse response. 1.73. What is the difference between the Domestic credit (% of GDP) in Latin America(developing only) in 2003 and the Domestic credit (% of GDP) in Sudan in 2007?
Offer a very short reply. 9.77. What is the difference between the Domestic credit (% of GDP) of Barbados in 2003 and the Domestic credit (% of GDP) of Dominican Republic in 2007?
Give a very brief answer. 40.4. What is the difference between the Domestic credit (% of GDP) in Barbados in 2003 and the Domestic credit (% of GDP) in Sudan in 2007?
Provide a succinct answer. 48.45. What is the difference between the Domestic credit (% of GDP) in Dominican Republic in 2003 and the Domestic credit (% of GDP) in Sudan in 2007?
Make the answer very short. 24.8. What is the difference between the Domestic credit (% of GDP) in Latin America(developing only) in 2003 and the Domestic credit (% of GDP) in Barbados in 2008?
Your answer should be very brief. -56.35. What is the difference between the Domestic credit (% of GDP) in Latin America(developing only) in 2003 and the Domestic credit (% of GDP) in Dominican Republic in 2008?
Ensure brevity in your answer.  1.69. What is the difference between the Domestic credit (% of GDP) in Latin America(developing only) in 2003 and the Domestic credit (% of GDP) in Sudan in 2008?
Ensure brevity in your answer.  11.33. What is the difference between the Domestic credit (% of GDP) of Barbados in 2003 and the Domestic credit (% of GDP) of Dominican Republic in 2008?
Offer a terse response. 40.37. What is the difference between the Domestic credit (% of GDP) in Barbados in 2003 and the Domestic credit (% of GDP) in Sudan in 2008?
Provide a succinct answer. 50. What is the difference between the Domestic credit (% of GDP) of Dominican Republic in 2003 and the Domestic credit (% of GDP) of Sudan in 2008?
Offer a very short reply. 26.36. What is the difference between the Domestic credit (% of GDP) of Latin America(developing only) in 2004 and the Domestic credit (% of GDP) of Barbados in 2005?
Your response must be concise. -48.29. What is the difference between the Domestic credit (% of GDP) of Latin America(developing only) in 2004 and the Domestic credit (% of GDP) of Dominican Republic in 2005?
Provide a succinct answer. 2.15. What is the difference between the Domestic credit (% of GDP) of Latin America(developing only) in 2004 and the Domestic credit (% of GDP) of Sudan in 2005?
Offer a terse response. 12.66. What is the difference between the Domestic credit (% of GDP) of Barbados in 2004 and the Domestic credit (% of GDP) of Dominican Republic in 2005?
Offer a terse response. 45.06. What is the difference between the Domestic credit (% of GDP) in Barbados in 2004 and the Domestic credit (% of GDP) in Sudan in 2005?
Provide a succinct answer. 55.56. What is the difference between the Domestic credit (% of GDP) of Dominican Republic in 2004 and the Domestic credit (% of GDP) of Sudan in 2005?
Ensure brevity in your answer.  13.98. What is the difference between the Domestic credit (% of GDP) of Latin America(developing only) in 2004 and the Domestic credit (% of GDP) of Barbados in 2006?
Offer a very short reply. -49.18. What is the difference between the Domestic credit (% of GDP) in Latin America(developing only) in 2004 and the Domestic credit (% of GDP) in Dominican Republic in 2006?
Provide a short and direct response. 3.21. What is the difference between the Domestic credit (% of GDP) of Latin America(developing only) in 2004 and the Domestic credit (% of GDP) of Sudan in 2006?
Offer a terse response. 9.06. What is the difference between the Domestic credit (% of GDP) of Barbados in 2004 and the Domestic credit (% of GDP) of Dominican Republic in 2006?
Keep it short and to the point. 46.11. What is the difference between the Domestic credit (% of GDP) of Barbados in 2004 and the Domestic credit (% of GDP) of Sudan in 2006?
Your answer should be very brief. 51.97. What is the difference between the Domestic credit (% of GDP) in Dominican Republic in 2004 and the Domestic credit (% of GDP) in Sudan in 2006?
Your answer should be very brief. 10.38. What is the difference between the Domestic credit (% of GDP) of Latin America(developing only) in 2004 and the Domestic credit (% of GDP) of Barbados in 2007?
Give a very brief answer. -50.32. What is the difference between the Domestic credit (% of GDP) of Latin America(developing only) in 2004 and the Domestic credit (% of GDP) of Dominican Republic in 2007?
Your response must be concise. 2.27. What is the difference between the Domestic credit (% of GDP) in Latin America(developing only) in 2004 and the Domestic credit (% of GDP) in Sudan in 2007?
Give a very brief answer. 10.32. What is the difference between the Domestic credit (% of GDP) in Barbados in 2004 and the Domestic credit (% of GDP) in Dominican Republic in 2007?
Provide a succinct answer. 45.18. What is the difference between the Domestic credit (% of GDP) in Barbados in 2004 and the Domestic credit (% of GDP) in Sudan in 2007?
Ensure brevity in your answer.  53.22. What is the difference between the Domestic credit (% of GDP) in Dominican Republic in 2004 and the Domestic credit (% of GDP) in Sudan in 2007?
Offer a terse response. 11.63. What is the difference between the Domestic credit (% of GDP) in Latin America(developing only) in 2004 and the Domestic credit (% of GDP) in Barbados in 2008?
Your response must be concise. -55.81. What is the difference between the Domestic credit (% of GDP) in Latin America(developing only) in 2004 and the Domestic credit (% of GDP) in Dominican Republic in 2008?
Your answer should be compact. 2.24. What is the difference between the Domestic credit (% of GDP) of Latin America(developing only) in 2004 and the Domestic credit (% of GDP) of Sudan in 2008?
Your answer should be compact. 11.87. What is the difference between the Domestic credit (% of GDP) of Barbados in 2004 and the Domestic credit (% of GDP) of Dominican Republic in 2008?
Your answer should be compact. 45.14. What is the difference between the Domestic credit (% of GDP) of Barbados in 2004 and the Domestic credit (% of GDP) of Sudan in 2008?
Ensure brevity in your answer.  54.78. What is the difference between the Domestic credit (% of GDP) of Dominican Republic in 2004 and the Domestic credit (% of GDP) of Sudan in 2008?
Provide a short and direct response. 13.19. What is the difference between the Domestic credit (% of GDP) in Latin America(developing only) in 2005 and the Domestic credit (% of GDP) in Barbados in 2006?
Provide a short and direct response. -47.01. What is the difference between the Domestic credit (% of GDP) of Latin America(developing only) in 2005 and the Domestic credit (% of GDP) of Dominican Republic in 2006?
Offer a very short reply. 5.38. What is the difference between the Domestic credit (% of GDP) of Latin America(developing only) in 2005 and the Domestic credit (% of GDP) of Sudan in 2006?
Make the answer very short. 11.24. What is the difference between the Domestic credit (% of GDP) in Barbados in 2005 and the Domestic credit (% of GDP) in Dominican Republic in 2006?
Your response must be concise. 51.49. What is the difference between the Domestic credit (% of GDP) of Barbados in 2005 and the Domestic credit (% of GDP) of Sudan in 2006?
Give a very brief answer. 57.35. What is the difference between the Domestic credit (% of GDP) of Dominican Republic in 2005 and the Domestic credit (% of GDP) of Sudan in 2006?
Your response must be concise. 6.91. What is the difference between the Domestic credit (% of GDP) of Latin America(developing only) in 2005 and the Domestic credit (% of GDP) of Barbados in 2007?
Offer a very short reply. -48.15. What is the difference between the Domestic credit (% of GDP) in Latin America(developing only) in 2005 and the Domestic credit (% of GDP) in Dominican Republic in 2007?
Your answer should be compact. 4.45. What is the difference between the Domestic credit (% of GDP) of Latin America(developing only) in 2005 and the Domestic credit (% of GDP) of Sudan in 2007?
Give a very brief answer. 12.49. What is the difference between the Domestic credit (% of GDP) of Barbados in 2005 and the Domestic credit (% of GDP) of Dominican Republic in 2007?
Your answer should be very brief. 50.55. What is the difference between the Domestic credit (% of GDP) of Barbados in 2005 and the Domestic credit (% of GDP) of Sudan in 2007?
Your answer should be very brief. 58.6. What is the difference between the Domestic credit (% of GDP) of Dominican Republic in 2005 and the Domestic credit (% of GDP) of Sudan in 2007?
Provide a succinct answer. 8.16. What is the difference between the Domestic credit (% of GDP) of Latin America(developing only) in 2005 and the Domestic credit (% of GDP) of Barbados in 2008?
Provide a short and direct response. -53.63. What is the difference between the Domestic credit (% of GDP) of Latin America(developing only) in 2005 and the Domestic credit (% of GDP) of Dominican Republic in 2008?
Offer a terse response. 4.41. What is the difference between the Domestic credit (% of GDP) in Latin America(developing only) in 2005 and the Domestic credit (% of GDP) in Sudan in 2008?
Your answer should be compact. 14.05. What is the difference between the Domestic credit (% of GDP) of Barbados in 2005 and the Domestic credit (% of GDP) of Dominican Republic in 2008?
Make the answer very short. 50.52. What is the difference between the Domestic credit (% of GDP) in Barbados in 2005 and the Domestic credit (% of GDP) in Sudan in 2008?
Offer a very short reply. 60.16. What is the difference between the Domestic credit (% of GDP) in Dominican Republic in 2005 and the Domestic credit (% of GDP) in Sudan in 2008?
Offer a very short reply. 9.72. What is the difference between the Domestic credit (% of GDP) of Latin America(developing only) in 2006 and the Domestic credit (% of GDP) of Barbados in 2007?
Offer a very short reply. -44.56. What is the difference between the Domestic credit (% of GDP) of Latin America(developing only) in 2006 and the Domestic credit (% of GDP) of Dominican Republic in 2007?
Your answer should be compact. 8.03. What is the difference between the Domestic credit (% of GDP) in Latin America(developing only) in 2006 and the Domestic credit (% of GDP) in Sudan in 2007?
Give a very brief answer. 16.08. What is the difference between the Domestic credit (% of GDP) in Barbados in 2006 and the Domestic credit (% of GDP) in Dominican Republic in 2007?
Give a very brief answer. 51.45. What is the difference between the Domestic credit (% of GDP) in Barbados in 2006 and the Domestic credit (% of GDP) in Sudan in 2007?
Provide a succinct answer. 59.5. What is the difference between the Domestic credit (% of GDP) in Dominican Republic in 2006 and the Domestic credit (% of GDP) in Sudan in 2007?
Provide a short and direct response. 7.11. What is the difference between the Domestic credit (% of GDP) of Latin America(developing only) in 2006 and the Domestic credit (% of GDP) of Barbados in 2008?
Your answer should be very brief. -50.04. What is the difference between the Domestic credit (% of GDP) of Latin America(developing only) in 2006 and the Domestic credit (% of GDP) of Dominican Republic in 2008?
Provide a short and direct response. 8. What is the difference between the Domestic credit (% of GDP) of Latin America(developing only) in 2006 and the Domestic credit (% of GDP) of Sudan in 2008?
Make the answer very short. 17.64. What is the difference between the Domestic credit (% of GDP) of Barbados in 2006 and the Domestic credit (% of GDP) of Dominican Republic in 2008?
Your answer should be compact. 51.42. What is the difference between the Domestic credit (% of GDP) of Barbados in 2006 and the Domestic credit (% of GDP) of Sudan in 2008?
Offer a terse response. 61.05. What is the difference between the Domestic credit (% of GDP) of Dominican Republic in 2006 and the Domestic credit (% of GDP) of Sudan in 2008?
Your answer should be very brief. 8.66. What is the difference between the Domestic credit (% of GDP) in Latin America(developing only) in 2007 and the Domestic credit (% of GDP) in Barbados in 2008?
Keep it short and to the point. -45.64. What is the difference between the Domestic credit (% of GDP) in Latin America(developing only) in 2007 and the Domestic credit (% of GDP) in Dominican Republic in 2008?
Your answer should be compact. 12.41. What is the difference between the Domestic credit (% of GDP) of Latin America(developing only) in 2007 and the Domestic credit (% of GDP) of Sudan in 2008?
Your response must be concise. 22.04. What is the difference between the Domestic credit (% of GDP) in Barbados in 2007 and the Domestic credit (% of GDP) in Dominican Republic in 2008?
Give a very brief answer. 52.56. What is the difference between the Domestic credit (% of GDP) of Barbados in 2007 and the Domestic credit (% of GDP) of Sudan in 2008?
Provide a succinct answer. 62.19. What is the difference between the Domestic credit (% of GDP) in Dominican Republic in 2007 and the Domestic credit (% of GDP) in Sudan in 2008?
Your answer should be very brief. 9.6. What is the average Domestic credit (% of GDP) of Latin America(developing only) per year?
Provide a short and direct response. 26.67. What is the average Domestic credit (% of GDP) of Barbados per year?
Your answer should be very brief. 67.51. What is the average Domestic credit (% of GDP) of Dominican Republic per year?
Make the answer very short. 26.31. What is the average Domestic credit (% of GDP) in Sudan per year?
Make the answer very short. 8.68. In the year 2001, what is the difference between the Domestic credit (% of GDP) in Latin America(developing only) and Domestic credit (% of GDP) in Barbados?
Provide a succinct answer. -36.27. In the year 2001, what is the difference between the Domestic credit (% of GDP) in Latin America(developing only) and Domestic credit (% of GDP) in Dominican Republic?
Your answer should be compact. -10.88. In the year 2001, what is the difference between the Domestic credit (% of GDP) in Latin America(developing only) and Domestic credit (% of GDP) in Sudan?
Keep it short and to the point. 18.83. In the year 2001, what is the difference between the Domestic credit (% of GDP) of Barbados and Domestic credit (% of GDP) of Dominican Republic?
Your response must be concise. 25.39. In the year 2001, what is the difference between the Domestic credit (% of GDP) of Barbados and Domestic credit (% of GDP) of Sudan?
Provide a succinct answer. 55.1. In the year 2001, what is the difference between the Domestic credit (% of GDP) in Dominican Republic and Domestic credit (% of GDP) in Sudan?
Make the answer very short. 29.71. In the year 2002, what is the difference between the Domestic credit (% of GDP) in Latin America(developing only) and Domestic credit (% of GDP) in Barbados?
Offer a terse response. -36.57. In the year 2002, what is the difference between the Domestic credit (% of GDP) of Latin America(developing only) and Domestic credit (% of GDP) of Dominican Republic?
Provide a succinct answer. -11.03. In the year 2002, what is the difference between the Domestic credit (% of GDP) in Latin America(developing only) and Domestic credit (% of GDP) in Sudan?
Offer a very short reply. 18.1. In the year 2002, what is the difference between the Domestic credit (% of GDP) in Barbados and Domestic credit (% of GDP) in Dominican Republic?
Provide a short and direct response. 25.54. In the year 2002, what is the difference between the Domestic credit (% of GDP) in Barbados and Domestic credit (% of GDP) in Sudan?
Your answer should be compact. 54.67. In the year 2002, what is the difference between the Domestic credit (% of GDP) in Dominican Republic and Domestic credit (% of GDP) in Sudan?
Ensure brevity in your answer.  29.13. In the year 2003, what is the difference between the Domestic credit (% of GDP) of Latin America(developing only) and Domestic credit (% of GDP) of Barbados?
Provide a short and direct response. -38.68. In the year 2003, what is the difference between the Domestic credit (% of GDP) of Latin America(developing only) and Domestic credit (% of GDP) of Dominican Republic?
Provide a short and direct response. -15.03. In the year 2003, what is the difference between the Domestic credit (% of GDP) of Latin America(developing only) and Domestic credit (% of GDP) of Sudan?
Your response must be concise. 16.41. In the year 2003, what is the difference between the Domestic credit (% of GDP) of Barbados and Domestic credit (% of GDP) of Dominican Republic?
Offer a terse response. 23.64. In the year 2003, what is the difference between the Domestic credit (% of GDP) of Barbados and Domestic credit (% of GDP) of Sudan?
Make the answer very short. 55.08. In the year 2003, what is the difference between the Domestic credit (% of GDP) in Dominican Republic and Domestic credit (% of GDP) in Sudan?
Keep it short and to the point. 31.44. In the year 2004, what is the difference between the Domestic credit (% of GDP) of Latin America(developing only) and Domestic credit (% of GDP) of Barbados?
Your answer should be very brief. -42.91. In the year 2004, what is the difference between the Domestic credit (% of GDP) in Latin America(developing only) and Domestic credit (% of GDP) in Dominican Republic?
Offer a very short reply. -1.32. In the year 2004, what is the difference between the Domestic credit (% of GDP) in Latin America(developing only) and Domestic credit (% of GDP) in Sudan?
Give a very brief answer. 15.41. In the year 2004, what is the difference between the Domestic credit (% of GDP) of Barbados and Domestic credit (% of GDP) of Dominican Republic?
Provide a succinct answer. 41.59. In the year 2004, what is the difference between the Domestic credit (% of GDP) in Barbados and Domestic credit (% of GDP) in Sudan?
Make the answer very short. 58.32. In the year 2004, what is the difference between the Domestic credit (% of GDP) in Dominican Republic and Domestic credit (% of GDP) in Sudan?
Offer a very short reply. 16.73. In the year 2005, what is the difference between the Domestic credit (% of GDP) in Latin America(developing only) and Domestic credit (% of GDP) in Barbados?
Provide a succinct answer. -46.11. In the year 2005, what is the difference between the Domestic credit (% of GDP) in Latin America(developing only) and Domestic credit (% of GDP) in Dominican Republic?
Keep it short and to the point. 4.33. In the year 2005, what is the difference between the Domestic credit (% of GDP) in Latin America(developing only) and Domestic credit (% of GDP) in Sudan?
Your response must be concise. 14.84. In the year 2005, what is the difference between the Domestic credit (% of GDP) of Barbados and Domestic credit (% of GDP) of Dominican Republic?
Your response must be concise. 50.44. In the year 2005, what is the difference between the Domestic credit (% of GDP) in Barbados and Domestic credit (% of GDP) in Sudan?
Offer a very short reply. 60.94. In the year 2005, what is the difference between the Domestic credit (% of GDP) of Dominican Republic and Domestic credit (% of GDP) of Sudan?
Give a very brief answer. 10.51. In the year 2006, what is the difference between the Domestic credit (% of GDP) in Latin America(developing only) and Domestic credit (% of GDP) in Barbados?
Ensure brevity in your answer.  -43.42. In the year 2006, what is the difference between the Domestic credit (% of GDP) of Latin America(developing only) and Domestic credit (% of GDP) of Dominican Republic?
Ensure brevity in your answer.  8.97. In the year 2006, what is the difference between the Domestic credit (% of GDP) in Latin America(developing only) and Domestic credit (% of GDP) in Sudan?
Provide a short and direct response. 14.83. In the year 2006, what is the difference between the Domestic credit (% of GDP) in Barbados and Domestic credit (% of GDP) in Dominican Republic?
Provide a short and direct response. 52.39. In the year 2006, what is the difference between the Domestic credit (% of GDP) of Barbados and Domestic credit (% of GDP) of Sudan?
Offer a very short reply. 58.25. In the year 2006, what is the difference between the Domestic credit (% of GDP) of Dominican Republic and Domestic credit (% of GDP) of Sudan?
Ensure brevity in your answer.  5.86. In the year 2007, what is the difference between the Domestic credit (% of GDP) in Latin America(developing only) and Domestic credit (% of GDP) in Barbados?
Offer a terse response. -40.15. In the year 2007, what is the difference between the Domestic credit (% of GDP) of Latin America(developing only) and Domestic credit (% of GDP) of Dominican Republic?
Offer a very short reply. 12.44. In the year 2007, what is the difference between the Domestic credit (% of GDP) of Latin America(developing only) and Domestic credit (% of GDP) of Sudan?
Give a very brief answer. 20.48. In the year 2007, what is the difference between the Domestic credit (% of GDP) in Barbados and Domestic credit (% of GDP) in Dominican Republic?
Offer a very short reply. 52.59. In the year 2007, what is the difference between the Domestic credit (% of GDP) of Barbados and Domestic credit (% of GDP) of Sudan?
Offer a terse response. 60.64. In the year 2007, what is the difference between the Domestic credit (% of GDP) of Dominican Republic and Domestic credit (% of GDP) of Sudan?
Offer a very short reply. 8.05. In the year 2008, what is the difference between the Domestic credit (% of GDP) in Latin America(developing only) and Domestic credit (% of GDP) in Barbados?
Provide a short and direct response. -42.61. In the year 2008, what is the difference between the Domestic credit (% of GDP) of Latin America(developing only) and Domestic credit (% of GDP) of Dominican Republic?
Ensure brevity in your answer.  15.44. In the year 2008, what is the difference between the Domestic credit (% of GDP) in Latin America(developing only) and Domestic credit (% of GDP) in Sudan?
Offer a very short reply. 25.07. In the year 2008, what is the difference between the Domestic credit (% of GDP) in Barbados and Domestic credit (% of GDP) in Dominican Republic?
Give a very brief answer. 58.04. In the year 2008, what is the difference between the Domestic credit (% of GDP) of Barbados and Domestic credit (% of GDP) of Sudan?
Offer a terse response. 67.68. In the year 2008, what is the difference between the Domestic credit (% of GDP) of Dominican Republic and Domestic credit (% of GDP) of Sudan?
Give a very brief answer. 9.63. What is the ratio of the Domestic credit (% of GDP) in Latin America(developing only) in 2001 to that in 2002?
Your answer should be very brief. 0.96. What is the ratio of the Domestic credit (% of GDP) of Barbados in 2001 to that in 2002?
Your answer should be very brief. 0.98. What is the ratio of the Domestic credit (% of GDP) in Dominican Republic in 2001 to that in 2002?
Give a very brief answer. 0.97. What is the ratio of the Domestic credit (% of GDP) in Sudan in 2001 to that in 2002?
Provide a short and direct response. 0.65. What is the ratio of the Domestic credit (% of GDP) in Latin America(developing only) in 2001 to that in 2003?
Provide a succinct answer. 0.97. What is the ratio of the Domestic credit (% of GDP) in Barbados in 2001 to that in 2003?
Your answer should be very brief. 0.95. What is the ratio of the Domestic credit (% of GDP) in Dominican Republic in 2001 to that in 2003?
Offer a terse response. 0.87. What is the ratio of the Domestic credit (% of GDP) in Sudan in 2001 to that in 2003?
Offer a terse response. 0.49. What is the ratio of the Domestic credit (% of GDP) in Latin America(developing only) in 2001 to that in 2004?
Provide a short and direct response. 0.95. What is the ratio of the Domestic credit (% of GDP) of Barbados in 2001 to that in 2004?
Ensure brevity in your answer.  0.88. What is the ratio of the Domestic credit (% of GDP) of Dominican Republic in 2001 to that in 2004?
Keep it short and to the point. 1.34. What is the ratio of the Domestic credit (% of GDP) in Sudan in 2001 to that in 2004?
Offer a terse response. 0.39. What is the ratio of the Domestic credit (% of GDP) of Latin America(developing only) in 2001 to that in 2005?
Keep it short and to the point. 0.86. What is the ratio of the Domestic credit (% of GDP) of Barbados in 2001 to that in 2005?
Make the answer very short. 0.81. What is the ratio of the Domestic credit (% of GDP) of Dominican Republic in 2001 to that in 2005?
Your answer should be compact. 1.57. What is the ratio of the Domestic credit (% of GDP) of Sudan in 2001 to that in 2005?
Ensure brevity in your answer.  0.29. What is the ratio of the Domestic credit (% of GDP) in Latin America(developing only) in 2001 to that in 2006?
Provide a succinct answer. 0.76. What is the ratio of the Domestic credit (% of GDP) of Barbados in 2001 to that in 2006?
Keep it short and to the point. 0.8. What is the ratio of the Domestic credit (% of GDP) of Dominican Republic in 2001 to that in 2006?
Your answer should be compact. 1.65. What is the ratio of the Domestic credit (% of GDP) of Sudan in 2001 to that in 2006?
Offer a terse response. 0.21. What is the ratio of the Domestic credit (% of GDP) in Latin America(developing only) in 2001 to that in 2007?
Your response must be concise. 0.66. What is the ratio of the Domestic credit (% of GDP) of Barbados in 2001 to that in 2007?
Offer a terse response. 0.79. What is the ratio of the Domestic credit (% of GDP) in Dominican Republic in 2001 to that in 2007?
Keep it short and to the point. 1.57. What is the ratio of the Domestic credit (% of GDP) of Sudan in 2001 to that in 2007?
Your response must be concise. 0.23. What is the ratio of the Domestic credit (% of GDP) in Latin America(developing only) in 2001 to that in 2008?
Ensure brevity in your answer.  0.6. What is the ratio of the Domestic credit (% of GDP) in Barbados in 2001 to that in 2008?
Your answer should be very brief. 0.74. What is the ratio of the Domestic credit (% of GDP) of Dominican Republic in 2001 to that in 2008?
Your answer should be compact. 1.57. What is the ratio of the Domestic credit (% of GDP) in Sudan in 2001 to that in 2008?
Give a very brief answer. 0.27. What is the ratio of the Domestic credit (% of GDP) of Latin America(developing only) in 2002 to that in 2003?
Keep it short and to the point. 1.01. What is the ratio of the Domestic credit (% of GDP) of Barbados in 2002 to that in 2003?
Provide a short and direct response. 0.97. What is the ratio of the Domestic credit (% of GDP) in Dominican Republic in 2002 to that in 2003?
Provide a short and direct response. 0.9. What is the ratio of the Domestic credit (% of GDP) in Sudan in 2002 to that in 2003?
Offer a terse response. 0.75. What is the ratio of the Domestic credit (% of GDP) in Barbados in 2002 to that in 2004?
Provide a succinct answer. 0.9. What is the ratio of the Domestic credit (% of GDP) in Dominican Republic in 2002 to that in 2004?
Provide a short and direct response. 1.38. What is the ratio of the Domestic credit (% of GDP) in Sudan in 2002 to that in 2004?
Your answer should be compact. 0.6. What is the ratio of the Domestic credit (% of GDP) in Latin America(developing only) in 2002 to that in 2005?
Your response must be concise. 0.9. What is the ratio of the Domestic credit (% of GDP) in Barbados in 2002 to that in 2005?
Keep it short and to the point. 0.83. What is the ratio of the Domestic credit (% of GDP) of Dominican Republic in 2002 to that in 2005?
Give a very brief answer. 1.62. What is the ratio of the Domestic credit (% of GDP) in Sudan in 2002 to that in 2005?
Provide a short and direct response. 0.44. What is the ratio of the Domestic credit (% of GDP) in Latin America(developing only) in 2002 to that in 2006?
Make the answer very short. 0.79. What is the ratio of the Domestic credit (% of GDP) of Barbados in 2002 to that in 2006?
Your response must be concise. 0.82. What is the ratio of the Domestic credit (% of GDP) in Dominican Republic in 2002 to that in 2006?
Give a very brief answer. 1.7. What is the ratio of the Domestic credit (% of GDP) in Sudan in 2002 to that in 2006?
Offer a very short reply. 0.33. What is the ratio of the Domestic credit (% of GDP) in Latin America(developing only) in 2002 to that in 2007?
Keep it short and to the point. 0.68. What is the ratio of the Domestic credit (% of GDP) of Barbados in 2002 to that in 2007?
Ensure brevity in your answer.  0.81. What is the ratio of the Domestic credit (% of GDP) in Dominican Republic in 2002 to that in 2007?
Ensure brevity in your answer.  1.62. What is the ratio of the Domestic credit (% of GDP) in Sudan in 2002 to that in 2007?
Provide a short and direct response. 0.36. What is the ratio of the Domestic credit (% of GDP) in Latin America(developing only) in 2002 to that in 2008?
Your response must be concise. 0.63. What is the ratio of the Domestic credit (% of GDP) in Barbados in 2002 to that in 2008?
Make the answer very short. 0.75. What is the ratio of the Domestic credit (% of GDP) in Dominican Republic in 2002 to that in 2008?
Your response must be concise. 1.62. What is the ratio of the Domestic credit (% of GDP) in Sudan in 2002 to that in 2008?
Ensure brevity in your answer.  0.41. What is the ratio of the Domestic credit (% of GDP) in Latin America(developing only) in 2003 to that in 2004?
Provide a short and direct response. 0.98. What is the ratio of the Domestic credit (% of GDP) in Barbados in 2003 to that in 2004?
Provide a short and direct response. 0.93. What is the ratio of the Domestic credit (% of GDP) of Dominican Republic in 2003 to that in 2004?
Your response must be concise. 1.54. What is the ratio of the Domestic credit (% of GDP) of Sudan in 2003 to that in 2004?
Your answer should be compact. 0.8. What is the ratio of the Domestic credit (% of GDP) of Latin America(developing only) in 2003 to that in 2005?
Your answer should be very brief. 0.89. What is the ratio of the Domestic credit (% of GDP) of Barbados in 2003 to that in 2005?
Give a very brief answer. 0.86. What is the ratio of the Domestic credit (% of GDP) of Dominican Republic in 2003 to that in 2005?
Make the answer very short. 1.8. What is the ratio of the Domestic credit (% of GDP) in Sudan in 2003 to that in 2005?
Keep it short and to the point. 0.59. What is the ratio of the Domestic credit (% of GDP) of Latin America(developing only) in 2003 to that in 2006?
Offer a very short reply. 0.78. What is the ratio of the Domestic credit (% of GDP) of Barbados in 2003 to that in 2006?
Keep it short and to the point. 0.85. What is the ratio of the Domestic credit (% of GDP) in Dominican Republic in 2003 to that in 2006?
Make the answer very short. 1.89. What is the ratio of the Domestic credit (% of GDP) of Sudan in 2003 to that in 2006?
Ensure brevity in your answer.  0.43. What is the ratio of the Domestic credit (% of GDP) in Latin America(developing only) in 2003 to that in 2007?
Your answer should be compact. 0.68. What is the ratio of the Domestic credit (% of GDP) in Barbados in 2003 to that in 2007?
Your answer should be compact. 0.83. What is the ratio of the Domestic credit (% of GDP) of Dominican Republic in 2003 to that in 2007?
Your answer should be compact. 1.81. What is the ratio of the Domestic credit (% of GDP) of Sudan in 2003 to that in 2007?
Give a very brief answer. 0.48. What is the ratio of the Domestic credit (% of GDP) in Latin America(developing only) in 2003 to that in 2008?
Keep it short and to the point. 0.62. What is the ratio of the Domestic credit (% of GDP) of Barbados in 2003 to that in 2008?
Your answer should be compact. 0.78. What is the ratio of the Domestic credit (% of GDP) in Dominican Republic in 2003 to that in 2008?
Keep it short and to the point. 1.8. What is the ratio of the Domestic credit (% of GDP) in Sudan in 2003 to that in 2008?
Offer a terse response. 0.54. What is the ratio of the Domestic credit (% of GDP) of Latin America(developing only) in 2004 to that in 2005?
Make the answer very short. 0.91. What is the ratio of the Domestic credit (% of GDP) of Barbados in 2004 to that in 2005?
Give a very brief answer. 0.92. What is the ratio of the Domestic credit (% of GDP) of Dominican Republic in 2004 to that in 2005?
Give a very brief answer. 1.17. What is the ratio of the Domestic credit (% of GDP) of Sudan in 2004 to that in 2005?
Your response must be concise. 0.73. What is the ratio of the Domestic credit (% of GDP) in Latin America(developing only) in 2004 to that in 2006?
Provide a short and direct response. 0.8. What is the ratio of the Domestic credit (% of GDP) of Dominican Republic in 2004 to that in 2006?
Offer a terse response. 1.23. What is the ratio of the Domestic credit (% of GDP) of Sudan in 2004 to that in 2006?
Keep it short and to the point. 0.55. What is the ratio of the Domestic credit (% of GDP) in Latin America(developing only) in 2004 to that in 2007?
Keep it short and to the point. 0.69. What is the ratio of the Domestic credit (% of GDP) in Barbados in 2004 to that in 2007?
Provide a succinct answer. 0.9. What is the ratio of the Domestic credit (% of GDP) of Dominican Republic in 2004 to that in 2007?
Provide a succinct answer. 1.17. What is the ratio of the Domestic credit (% of GDP) in Sudan in 2004 to that in 2007?
Give a very brief answer. 0.6. What is the ratio of the Domestic credit (% of GDP) of Latin America(developing only) in 2004 to that in 2008?
Make the answer very short. 0.64. What is the ratio of the Domestic credit (% of GDP) in Barbados in 2004 to that in 2008?
Provide a succinct answer. 0.84. What is the ratio of the Domestic credit (% of GDP) of Dominican Republic in 2004 to that in 2008?
Provide a short and direct response. 1.17. What is the ratio of the Domestic credit (% of GDP) in Sudan in 2004 to that in 2008?
Make the answer very short. 0.68. What is the ratio of the Domestic credit (% of GDP) of Latin America(developing only) in 2005 to that in 2006?
Your answer should be very brief. 0.88. What is the ratio of the Domestic credit (% of GDP) in Barbados in 2005 to that in 2006?
Give a very brief answer. 0.99. What is the ratio of the Domestic credit (% of GDP) of Dominican Republic in 2005 to that in 2006?
Provide a short and direct response. 1.05. What is the ratio of the Domestic credit (% of GDP) in Sudan in 2005 to that in 2006?
Your response must be concise. 0.74. What is the ratio of the Domestic credit (% of GDP) in Latin America(developing only) in 2005 to that in 2007?
Offer a very short reply. 0.76. What is the ratio of the Domestic credit (% of GDP) in Barbados in 2005 to that in 2007?
Offer a terse response. 0.97. What is the ratio of the Domestic credit (% of GDP) in Sudan in 2005 to that in 2007?
Your answer should be compact. 0.82. What is the ratio of the Domestic credit (% of GDP) in Latin America(developing only) in 2005 to that in 2008?
Make the answer very short. 0.7. What is the ratio of the Domestic credit (% of GDP) in Barbados in 2005 to that in 2008?
Offer a very short reply. 0.9. What is the ratio of the Domestic credit (% of GDP) in Sudan in 2005 to that in 2008?
Give a very brief answer. 0.93. What is the ratio of the Domestic credit (% of GDP) in Latin America(developing only) in 2006 to that in 2007?
Ensure brevity in your answer.  0.87. What is the ratio of the Domestic credit (% of GDP) of Barbados in 2006 to that in 2007?
Your answer should be very brief. 0.98. What is the ratio of the Domestic credit (% of GDP) in Dominican Republic in 2006 to that in 2007?
Your answer should be compact. 0.95. What is the ratio of the Domestic credit (% of GDP) of Sudan in 2006 to that in 2007?
Your response must be concise. 1.1. What is the ratio of the Domestic credit (% of GDP) of Latin America(developing only) in 2006 to that in 2008?
Offer a very short reply. 0.79. What is the ratio of the Domestic credit (% of GDP) of Barbados in 2006 to that in 2008?
Provide a succinct answer. 0.92. What is the ratio of the Domestic credit (% of GDP) of Dominican Republic in 2006 to that in 2008?
Provide a short and direct response. 0.95. What is the ratio of the Domestic credit (% of GDP) in Sudan in 2006 to that in 2008?
Give a very brief answer. 1.25. What is the ratio of the Domestic credit (% of GDP) of Latin America(developing only) in 2007 to that in 2008?
Keep it short and to the point. 0.92. What is the ratio of the Domestic credit (% of GDP) of Barbados in 2007 to that in 2008?
Make the answer very short. 0.93. What is the ratio of the Domestic credit (% of GDP) in Dominican Republic in 2007 to that in 2008?
Offer a very short reply. 1. What is the ratio of the Domestic credit (% of GDP) of Sudan in 2007 to that in 2008?
Offer a terse response. 1.14. What is the difference between the highest and the second highest Domestic credit (% of GDP) in Latin America(developing only)?
Provide a short and direct response. 3.03. What is the difference between the highest and the second highest Domestic credit (% of GDP) of Barbados?
Make the answer very short. 5.48. What is the difference between the highest and the second highest Domestic credit (% of GDP) in Dominican Republic?
Provide a short and direct response. 3.8. What is the difference between the highest and the second highest Domestic credit (% of GDP) in Sudan?
Offer a very short reply. 1.25. What is the difference between the highest and the lowest Domestic credit (% of GDP) of Latin America(developing only)?
Your answer should be compact. 14.43. What is the difference between the highest and the lowest Domestic credit (% of GDP) in Barbados?
Offer a very short reply. 20.76. What is the difference between the highest and the lowest Domestic credit (% of GDP) of Dominican Republic?
Provide a succinct answer. 17.7. What is the difference between the highest and the lowest Domestic credit (% of GDP) of Sudan?
Provide a succinct answer. 10.99. 